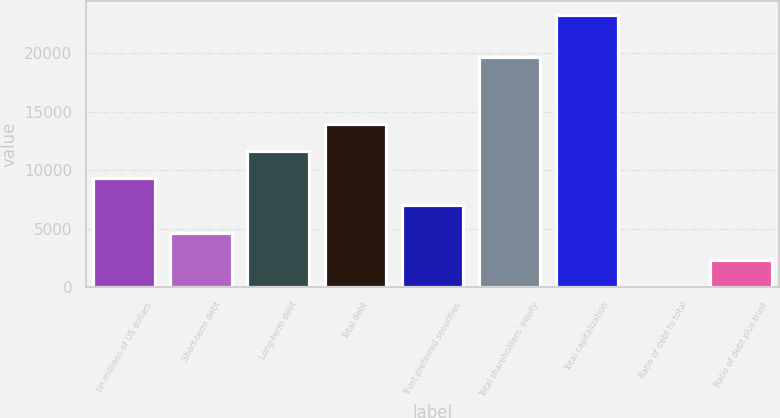Convert chart to OTSL. <chart><loc_0><loc_0><loc_500><loc_500><bar_chart><fcel>(in millions of US dollars<fcel>Short-term debt<fcel>Long-term debt<fcel>Total debt<fcel>Trust preferred securities<fcel>Total shareholders' equity<fcel>Total capitalization<fcel>Ratio of debt to total<fcel>Ratio of debt plus trust<nl><fcel>9326.52<fcel>4670.36<fcel>11654.6<fcel>13982.7<fcel>6998.44<fcel>19667<fcel>23295<fcel>14.2<fcel>2342.28<nl></chart> 